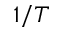Convert formula to latex. <formula><loc_0><loc_0><loc_500><loc_500>1 / T</formula> 